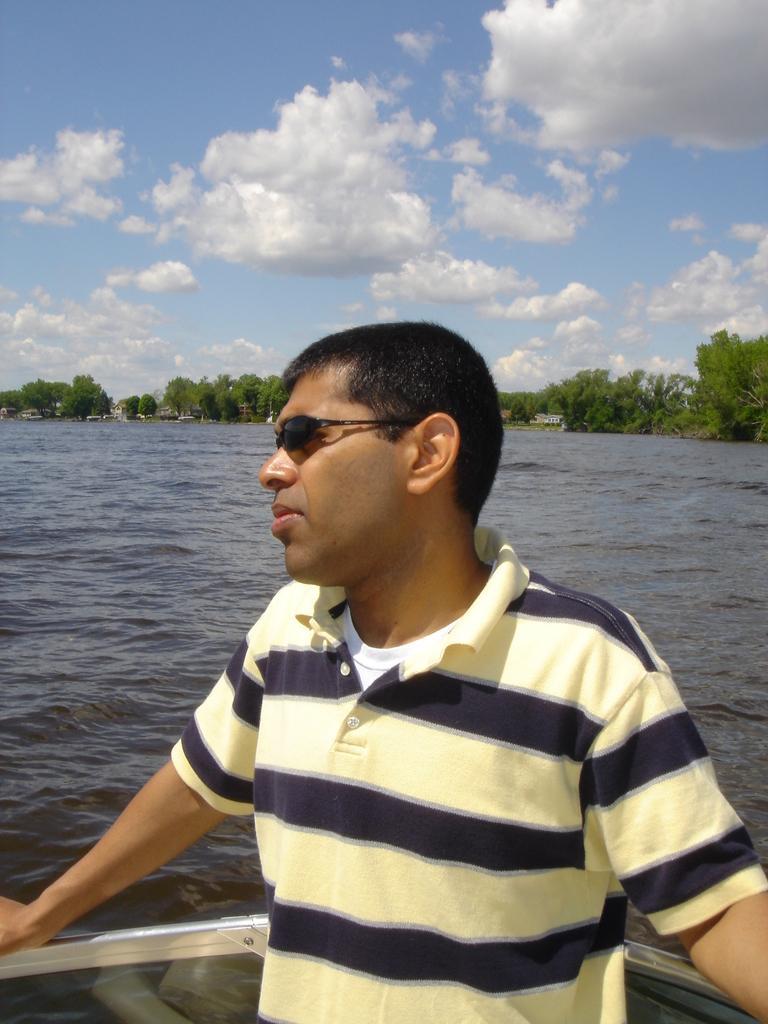How would you summarize this image in a sentence or two? In this image we can see a person is standing. There are many trees in the image. There is a blue and cloudy sky in the image. There is a sea in the image. 